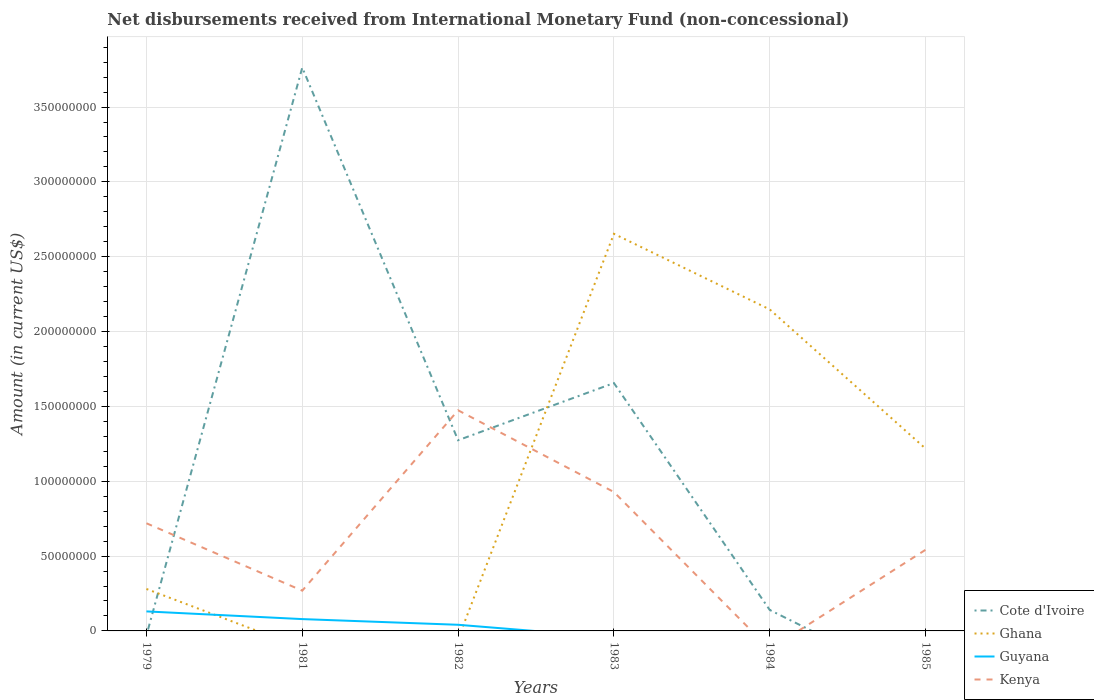How many different coloured lines are there?
Give a very brief answer. 4. Is the number of lines equal to the number of legend labels?
Keep it short and to the point. No. Across all years, what is the maximum amount of disbursements received from International Monetary Fund in Ghana?
Your answer should be compact. 0. What is the total amount of disbursements received from International Monetary Fund in Kenya in the graph?
Make the answer very short. 4.50e+07. What is the difference between the highest and the second highest amount of disbursements received from International Monetary Fund in Guyana?
Offer a terse response. 1.30e+07. How many lines are there?
Your response must be concise. 4. How many years are there in the graph?
Provide a short and direct response. 6. What is the difference between two consecutive major ticks on the Y-axis?
Ensure brevity in your answer.  5.00e+07. Are the values on the major ticks of Y-axis written in scientific E-notation?
Provide a succinct answer. No. Does the graph contain grids?
Provide a short and direct response. Yes. How are the legend labels stacked?
Provide a succinct answer. Vertical. What is the title of the graph?
Your answer should be compact. Net disbursements received from International Monetary Fund (non-concessional). Does "Finland" appear as one of the legend labels in the graph?
Your answer should be compact. No. What is the label or title of the X-axis?
Offer a terse response. Years. What is the label or title of the Y-axis?
Your response must be concise. Amount (in current US$). What is the Amount (in current US$) in Ghana in 1979?
Your answer should be compact. 2.80e+07. What is the Amount (in current US$) of Guyana in 1979?
Your answer should be very brief. 1.30e+07. What is the Amount (in current US$) in Kenya in 1979?
Give a very brief answer. 7.19e+07. What is the Amount (in current US$) of Cote d'Ivoire in 1981?
Provide a succinct answer. 3.76e+08. What is the Amount (in current US$) of Guyana in 1981?
Keep it short and to the point. 7.90e+06. What is the Amount (in current US$) of Kenya in 1981?
Your answer should be very brief. 2.69e+07. What is the Amount (in current US$) of Cote d'Ivoire in 1982?
Offer a terse response. 1.27e+08. What is the Amount (in current US$) in Ghana in 1982?
Your answer should be compact. 0. What is the Amount (in current US$) in Guyana in 1982?
Offer a terse response. 4.10e+06. What is the Amount (in current US$) in Kenya in 1982?
Give a very brief answer. 1.47e+08. What is the Amount (in current US$) in Cote d'Ivoire in 1983?
Your answer should be compact. 1.66e+08. What is the Amount (in current US$) of Ghana in 1983?
Ensure brevity in your answer.  2.65e+08. What is the Amount (in current US$) in Guyana in 1983?
Give a very brief answer. 0. What is the Amount (in current US$) of Kenya in 1983?
Give a very brief answer. 9.28e+07. What is the Amount (in current US$) of Cote d'Ivoire in 1984?
Your answer should be compact. 1.40e+07. What is the Amount (in current US$) in Ghana in 1984?
Your answer should be compact. 2.15e+08. What is the Amount (in current US$) of Guyana in 1984?
Offer a very short reply. 0. What is the Amount (in current US$) of Cote d'Ivoire in 1985?
Provide a succinct answer. 0. What is the Amount (in current US$) in Ghana in 1985?
Provide a succinct answer. 1.22e+08. What is the Amount (in current US$) of Guyana in 1985?
Keep it short and to the point. 0. What is the Amount (in current US$) in Kenya in 1985?
Offer a very short reply. 5.42e+07. Across all years, what is the maximum Amount (in current US$) of Cote d'Ivoire?
Make the answer very short. 3.76e+08. Across all years, what is the maximum Amount (in current US$) in Ghana?
Provide a short and direct response. 2.65e+08. Across all years, what is the maximum Amount (in current US$) of Guyana?
Your response must be concise. 1.30e+07. Across all years, what is the maximum Amount (in current US$) of Kenya?
Provide a short and direct response. 1.47e+08. Across all years, what is the minimum Amount (in current US$) of Ghana?
Your answer should be very brief. 0. Across all years, what is the minimum Amount (in current US$) of Kenya?
Provide a short and direct response. 0. What is the total Amount (in current US$) of Cote d'Ivoire in the graph?
Offer a very short reply. 6.83e+08. What is the total Amount (in current US$) in Ghana in the graph?
Your answer should be compact. 6.30e+08. What is the total Amount (in current US$) in Guyana in the graph?
Your answer should be compact. 2.50e+07. What is the total Amount (in current US$) in Kenya in the graph?
Give a very brief answer. 3.93e+08. What is the difference between the Amount (in current US$) in Guyana in 1979 and that in 1981?
Provide a short and direct response. 5.14e+06. What is the difference between the Amount (in current US$) in Kenya in 1979 and that in 1981?
Your answer should be compact. 4.50e+07. What is the difference between the Amount (in current US$) in Guyana in 1979 and that in 1982?
Offer a terse response. 8.94e+06. What is the difference between the Amount (in current US$) in Kenya in 1979 and that in 1982?
Your response must be concise. -7.55e+07. What is the difference between the Amount (in current US$) of Ghana in 1979 and that in 1983?
Keep it short and to the point. -2.37e+08. What is the difference between the Amount (in current US$) of Kenya in 1979 and that in 1983?
Make the answer very short. -2.09e+07. What is the difference between the Amount (in current US$) in Ghana in 1979 and that in 1984?
Make the answer very short. -1.87e+08. What is the difference between the Amount (in current US$) of Ghana in 1979 and that in 1985?
Provide a short and direct response. -9.38e+07. What is the difference between the Amount (in current US$) in Kenya in 1979 and that in 1985?
Offer a very short reply. 1.77e+07. What is the difference between the Amount (in current US$) in Cote d'Ivoire in 1981 and that in 1982?
Your response must be concise. 2.49e+08. What is the difference between the Amount (in current US$) in Guyana in 1981 and that in 1982?
Give a very brief answer. 3.80e+06. What is the difference between the Amount (in current US$) of Kenya in 1981 and that in 1982?
Your answer should be compact. -1.20e+08. What is the difference between the Amount (in current US$) of Cote d'Ivoire in 1981 and that in 1983?
Provide a short and direct response. 2.11e+08. What is the difference between the Amount (in current US$) of Kenya in 1981 and that in 1983?
Offer a terse response. -6.59e+07. What is the difference between the Amount (in current US$) in Cote d'Ivoire in 1981 and that in 1984?
Ensure brevity in your answer.  3.62e+08. What is the difference between the Amount (in current US$) in Kenya in 1981 and that in 1985?
Offer a terse response. -2.73e+07. What is the difference between the Amount (in current US$) of Cote d'Ivoire in 1982 and that in 1983?
Give a very brief answer. -3.82e+07. What is the difference between the Amount (in current US$) of Kenya in 1982 and that in 1983?
Offer a terse response. 5.46e+07. What is the difference between the Amount (in current US$) in Cote d'Ivoire in 1982 and that in 1984?
Keep it short and to the point. 1.13e+08. What is the difference between the Amount (in current US$) in Kenya in 1982 and that in 1985?
Give a very brief answer. 9.32e+07. What is the difference between the Amount (in current US$) of Cote d'Ivoire in 1983 and that in 1984?
Give a very brief answer. 1.52e+08. What is the difference between the Amount (in current US$) in Ghana in 1983 and that in 1984?
Your answer should be compact. 5.05e+07. What is the difference between the Amount (in current US$) in Ghana in 1983 and that in 1985?
Provide a short and direct response. 1.44e+08. What is the difference between the Amount (in current US$) in Kenya in 1983 and that in 1985?
Your answer should be compact. 3.86e+07. What is the difference between the Amount (in current US$) of Ghana in 1984 and that in 1985?
Provide a short and direct response. 9.30e+07. What is the difference between the Amount (in current US$) of Ghana in 1979 and the Amount (in current US$) of Guyana in 1981?
Ensure brevity in your answer.  2.01e+07. What is the difference between the Amount (in current US$) of Ghana in 1979 and the Amount (in current US$) of Kenya in 1981?
Provide a succinct answer. 1.14e+06. What is the difference between the Amount (in current US$) of Guyana in 1979 and the Amount (in current US$) of Kenya in 1981?
Your answer should be very brief. -1.39e+07. What is the difference between the Amount (in current US$) in Ghana in 1979 and the Amount (in current US$) in Guyana in 1982?
Make the answer very short. 2.39e+07. What is the difference between the Amount (in current US$) of Ghana in 1979 and the Amount (in current US$) of Kenya in 1982?
Your response must be concise. -1.19e+08. What is the difference between the Amount (in current US$) in Guyana in 1979 and the Amount (in current US$) in Kenya in 1982?
Offer a terse response. -1.34e+08. What is the difference between the Amount (in current US$) of Ghana in 1979 and the Amount (in current US$) of Kenya in 1983?
Keep it short and to the point. -6.48e+07. What is the difference between the Amount (in current US$) in Guyana in 1979 and the Amount (in current US$) in Kenya in 1983?
Your response must be concise. -7.98e+07. What is the difference between the Amount (in current US$) in Ghana in 1979 and the Amount (in current US$) in Kenya in 1985?
Offer a very short reply. -2.62e+07. What is the difference between the Amount (in current US$) of Guyana in 1979 and the Amount (in current US$) of Kenya in 1985?
Keep it short and to the point. -4.12e+07. What is the difference between the Amount (in current US$) in Cote d'Ivoire in 1981 and the Amount (in current US$) in Guyana in 1982?
Your answer should be compact. 3.72e+08. What is the difference between the Amount (in current US$) of Cote d'Ivoire in 1981 and the Amount (in current US$) of Kenya in 1982?
Your answer should be compact. 2.29e+08. What is the difference between the Amount (in current US$) of Guyana in 1981 and the Amount (in current US$) of Kenya in 1982?
Make the answer very short. -1.40e+08. What is the difference between the Amount (in current US$) in Cote d'Ivoire in 1981 and the Amount (in current US$) in Ghana in 1983?
Your response must be concise. 1.11e+08. What is the difference between the Amount (in current US$) in Cote d'Ivoire in 1981 and the Amount (in current US$) in Kenya in 1983?
Provide a succinct answer. 2.84e+08. What is the difference between the Amount (in current US$) of Guyana in 1981 and the Amount (in current US$) of Kenya in 1983?
Make the answer very short. -8.49e+07. What is the difference between the Amount (in current US$) of Cote d'Ivoire in 1981 and the Amount (in current US$) of Ghana in 1984?
Give a very brief answer. 1.62e+08. What is the difference between the Amount (in current US$) in Cote d'Ivoire in 1981 and the Amount (in current US$) in Ghana in 1985?
Offer a very short reply. 2.55e+08. What is the difference between the Amount (in current US$) of Cote d'Ivoire in 1981 and the Amount (in current US$) of Kenya in 1985?
Your response must be concise. 3.22e+08. What is the difference between the Amount (in current US$) of Guyana in 1981 and the Amount (in current US$) of Kenya in 1985?
Offer a terse response. -4.63e+07. What is the difference between the Amount (in current US$) of Cote d'Ivoire in 1982 and the Amount (in current US$) of Ghana in 1983?
Your response must be concise. -1.38e+08. What is the difference between the Amount (in current US$) in Cote d'Ivoire in 1982 and the Amount (in current US$) in Kenya in 1983?
Make the answer very short. 3.46e+07. What is the difference between the Amount (in current US$) of Guyana in 1982 and the Amount (in current US$) of Kenya in 1983?
Provide a succinct answer. -8.87e+07. What is the difference between the Amount (in current US$) in Cote d'Ivoire in 1982 and the Amount (in current US$) in Ghana in 1984?
Make the answer very short. -8.74e+07. What is the difference between the Amount (in current US$) in Cote d'Ivoire in 1982 and the Amount (in current US$) in Ghana in 1985?
Make the answer very short. 5.60e+06. What is the difference between the Amount (in current US$) in Cote d'Ivoire in 1982 and the Amount (in current US$) in Kenya in 1985?
Your answer should be compact. 7.32e+07. What is the difference between the Amount (in current US$) of Guyana in 1982 and the Amount (in current US$) of Kenya in 1985?
Your answer should be very brief. -5.01e+07. What is the difference between the Amount (in current US$) in Cote d'Ivoire in 1983 and the Amount (in current US$) in Ghana in 1984?
Offer a terse response. -4.92e+07. What is the difference between the Amount (in current US$) of Cote d'Ivoire in 1983 and the Amount (in current US$) of Ghana in 1985?
Ensure brevity in your answer.  4.38e+07. What is the difference between the Amount (in current US$) in Cote d'Ivoire in 1983 and the Amount (in current US$) in Kenya in 1985?
Your answer should be compact. 1.11e+08. What is the difference between the Amount (in current US$) of Ghana in 1983 and the Amount (in current US$) of Kenya in 1985?
Provide a short and direct response. 2.11e+08. What is the difference between the Amount (in current US$) in Cote d'Ivoire in 1984 and the Amount (in current US$) in Ghana in 1985?
Offer a very short reply. -1.08e+08. What is the difference between the Amount (in current US$) in Cote d'Ivoire in 1984 and the Amount (in current US$) in Kenya in 1985?
Offer a very short reply. -4.02e+07. What is the difference between the Amount (in current US$) of Ghana in 1984 and the Amount (in current US$) of Kenya in 1985?
Make the answer very short. 1.61e+08. What is the average Amount (in current US$) of Cote d'Ivoire per year?
Keep it short and to the point. 1.14e+08. What is the average Amount (in current US$) in Ghana per year?
Your response must be concise. 1.05e+08. What is the average Amount (in current US$) in Guyana per year?
Provide a short and direct response. 4.17e+06. What is the average Amount (in current US$) of Kenya per year?
Your answer should be compact. 6.55e+07. In the year 1979, what is the difference between the Amount (in current US$) of Ghana and Amount (in current US$) of Guyana?
Provide a short and direct response. 1.50e+07. In the year 1979, what is the difference between the Amount (in current US$) of Ghana and Amount (in current US$) of Kenya?
Ensure brevity in your answer.  -4.39e+07. In the year 1979, what is the difference between the Amount (in current US$) of Guyana and Amount (in current US$) of Kenya?
Ensure brevity in your answer.  -5.89e+07. In the year 1981, what is the difference between the Amount (in current US$) in Cote d'Ivoire and Amount (in current US$) in Guyana?
Your answer should be compact. 3.68e+08. In the year 1981, what is the difference between the Amount (in current US$) of Cote d'Ivoire and Amount (in current US$) of Kenya?
Keep it short and to the point. 3.49e+08. In the year 1981, what is the difference between the Amount (in current US$) in Guyana and Amount (in current US$) in Kenya?
Offer a terse response. -1.90e+07. In the year 1982, what is the difference between the Amount (in current US$) in Cote d'Ivoire and Amount (in current US$) in Guyana?
Make the answer very short. 1.23e+08. In the year 1982, what is the difference between the Amount (in current US$) of Cote d'Ivoire and Amount (in current US$) of Kenya?
Ensure brevity in your answer.  -2.00e+07. In the year 1982, what is the difference between the Amount (in current US$) of Guyana and Amount (in current US$) of Kenya?
Give a very brief answer. -1.43e+08. In the year 1983, what is the difference between the Amount (in current US$) of Cote d'Ivoire and Amount (in current US$) of Ghana?
Offer a very short reply. -9.97e+07. In the year 1983, what is the difference between the Amount (in current US$) of Cote d'Ivoire and Amount (in current US$) of Kenya?
Provide a succinct answer. 7.28e+07. In the year 1983, what is the difference between the Amount (in current US$) of Ghana and Amount (in current US$) of Kenya?
Offer a very short reply. 1.72e+08. In the year 1984, what is the difference between the Amount (in current US$) in Cote d'Ivoire and Amount (in current US$) in Ghana?
Provide a short and direct response. -2.01e+08. In the year 1985, what is the difference between the Amount (in current US$) in Ghana and Amount (in current US$) in Kenya?
Provide a succinct answer. 6.76e+07. What is the ratio of the Amount (in current US$) of Guyana in 1979 to that in 1981?
Your response must be concise. 1.65. What is the ratio of the Amount (in current US$) in Kenya in 1979 to that in 1981?
Provide a succinct answer. 2.67. What is the ratio of the Amount (in current US$) of Guyana in 1979 to that in 1982?
Provide a short and direct response. 3.18. What is the ratio of the Amount (in current US$) of Kenya in 1979 to that in 1982?
Offer a very short reply. 0.49. What is the ratio of the Amount (in current US$) of Ghana in 1979 to that in 1983?
Keep it short and to the point. 0.11. What is the ratio of the Amount (in current US$) in Kenya in 1979 to that in 1983?
Offer a very short reply. 0.78. What is the ratio of the Amount (in current US$) of Ghana in 1979 to that in 1984?
Give a very brief answer. 0.13. What is the ratio of the Amount (in current US$) in Ghana in 1979 to that in 1985?
Offer a very short reply. 0.23. What is the ratio of the Amount (in current US$) of Kenya in 1979 to that in 1985?
Provide a succinct answer. 1.33. What is the ratio of the Amount (in current US$) in Cote d'Ivoire in 1981 to that in 1982?
Keep it short and to the point. 2.95. What is the ratio of the Amount (in current US$) in Guyana in 1981 to that in 1982?
Keep it short and to the point. 1.93. What is the ratio of the Amount (in current US$) in Kenya in 1981 to that in 1982?
Ensure brevity in your answer.  0.18. What is the ratio of the Amount (in current US$) of Cote d'Ivoire in 1981 to that in 1983?
Provide a short and direct response. 2.27. What is the ratio of the Amount (in current US$) in Kenya in 1981 to that in 1983?
Offer a very short reply. 0.29. What is the ratio of the Amount (in current US$) of Cote d'Ivoire in 1981 to that in 1984?
Keep it short and to the point. 26.88. What is the ratio of the Amount (in current US$) of Kenya in 1981 to that in 1985?
Keep it short and to the point. 0.5. What is the ratio of the Amount (in current US$) of Cote d'Ivoire in 1982 to that in 1983?
Your answer should be very brief. 0.77. What is the ratio of the Amount (in current US$) of Kenya in 1982 to that in 1983?
Offer a terse response. 1.59. What is the ratio of the Amount (in current US$) of Kenya in 1982 to that in 1985?
Keep it short and to the point. 2.72. What is the ratio of the Amount (in current US$) in Cote d'Ivoire in 1983 to that in 1984?
Offer a terse response. 11.83. What is the ratio of the Amount (in current US$) of Ghana in 1983 to that in 1984?
Your answer should be very brief. 1.24. What is the ratio of the Amount (in current US$) of Ghana in 1983 to that in 1985?
Provide a succinct answer. 2.18. What is the ratio of the Amount (in current US$) in Kenya in 1983 to that in 1985?
Make the answer very short. 1.71. What is the ratio of the Amount (in current US$) in Ghana in 1984 to that in 1985?
Ensure brevity in your answer.  1.76. What is the difference between the highest and the second highest Amount (in current US$) in Cote d'Ivoire?
Ensure brevity in your answer.  2.11e+08. What is the difference between the highest and the second highest Amount (in current US$) of Ghana?
Give a very brief answer. 5.05e+07. What is the difference between the highest and the second highest Amount (in current US$) of Guyana?
Provide a short and direct response. 5.14e+06. What is the difference between the highest and the second highest Amount (in current US$) in Kenya?
Provide a short and direct response. 5.46e+07. What is the difference between the highest and the lowest Amount (in current US$) in Cote d'Ivoire?
Your response must be concise. 3.76e+08. What is the difference between the highest and the lowest Amount (in current US$) in Ghana?
Give a very brief answer. 2.65e+08. What is the difference between the highest and the lowest Amount (in current US$) of Guyana?
Your response must be concise. 1.30e+07. What is the difference between the highest and the lowest Amount (in current US$) in Kenya?
Provide a short and direct response. 1.47e+08. 